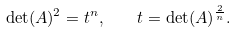Convert formula to latex. <formula><loc_0><loc_0><loc_500><loc_500>\det ( A ) ^ { 2 } = t ^ { n } , \quad t = \det ( A ) ^ { \frac { 2 } { n } } .</formula> 